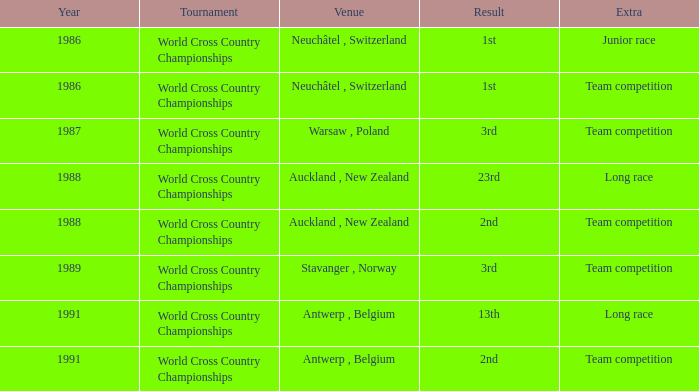Which venue had an extra of Junior Race? Neuchâtel , Switzerland. 